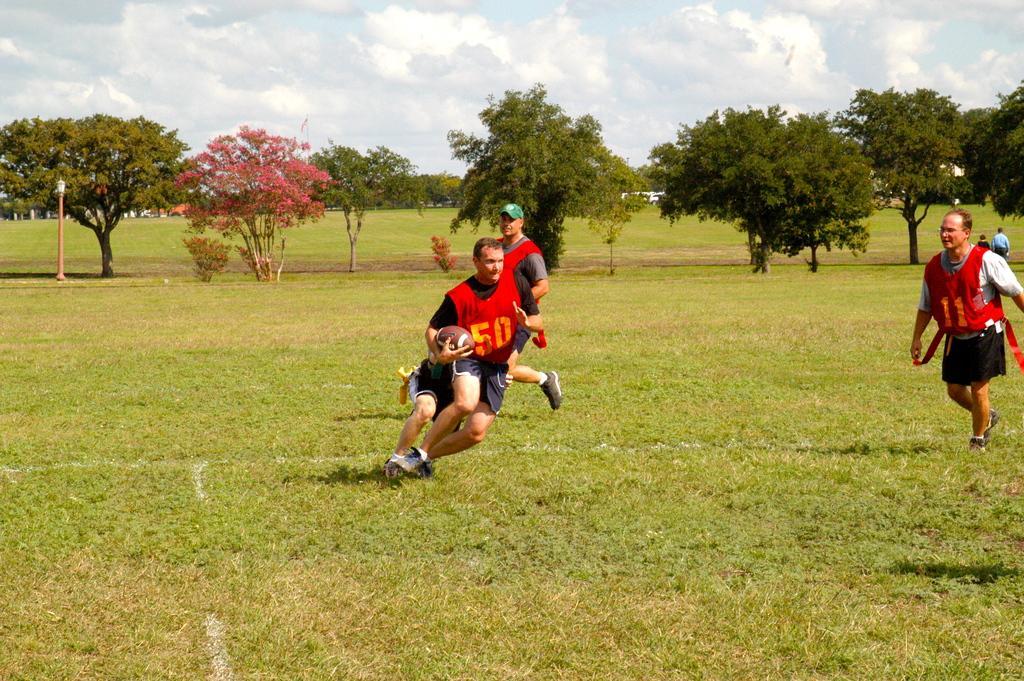Describe this image in one or two sentences. In this image there is a person holding the ball. Behind him there are two people. On the right side of the image there are people walking. At the bottom of the image there is grass on the surface. In the background of the image there is a light pole. There are trees, buildings and sky. 